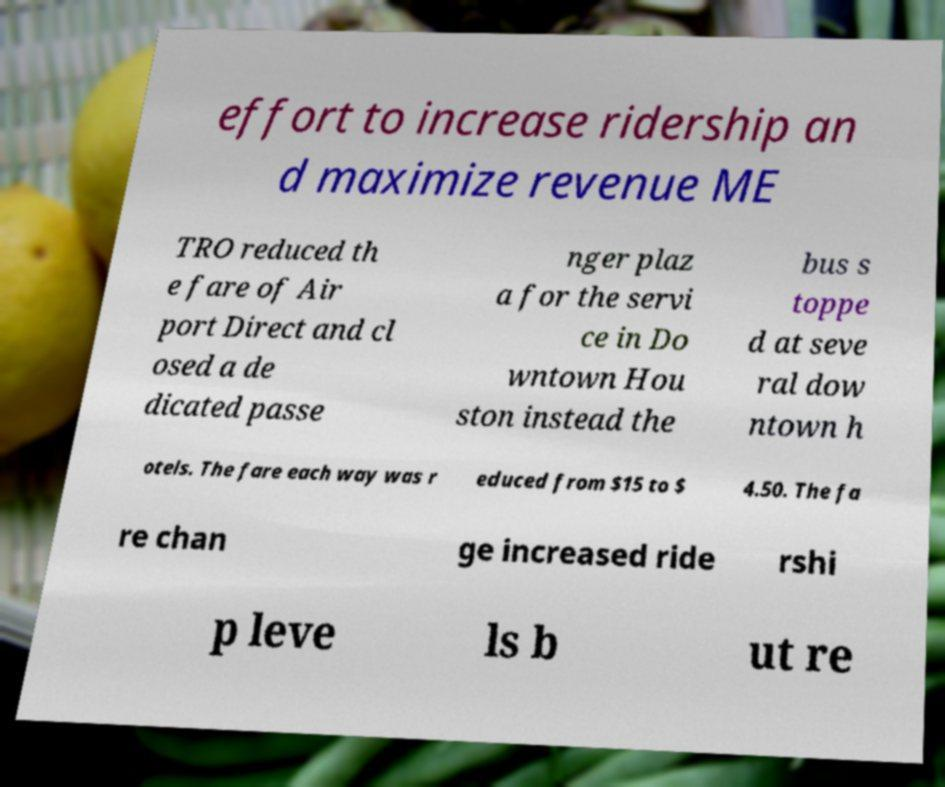Could you assist in decoding the text presented in this image and type it out clearly? effort to increase ridership an d maximize revenue ME TRO reduced th e fare of Air port Direct and cl osed a de dicated passe nger plaz a for the servi ce in Do wntown Hou ston instead the bus s toppe d at seve ral dow ntown h otels. The fare each way was r educed from $15 to $ 4.50. The fa re chan ge increased ride rshi p leve ls b ut re 